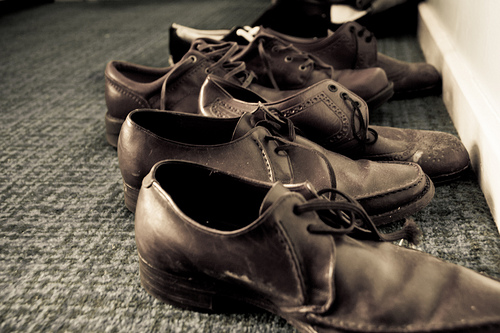<image>
Is the shoe under the shoe? No. The shoe is not positioned under the shoe. The vertical relationship between these objects is different. 